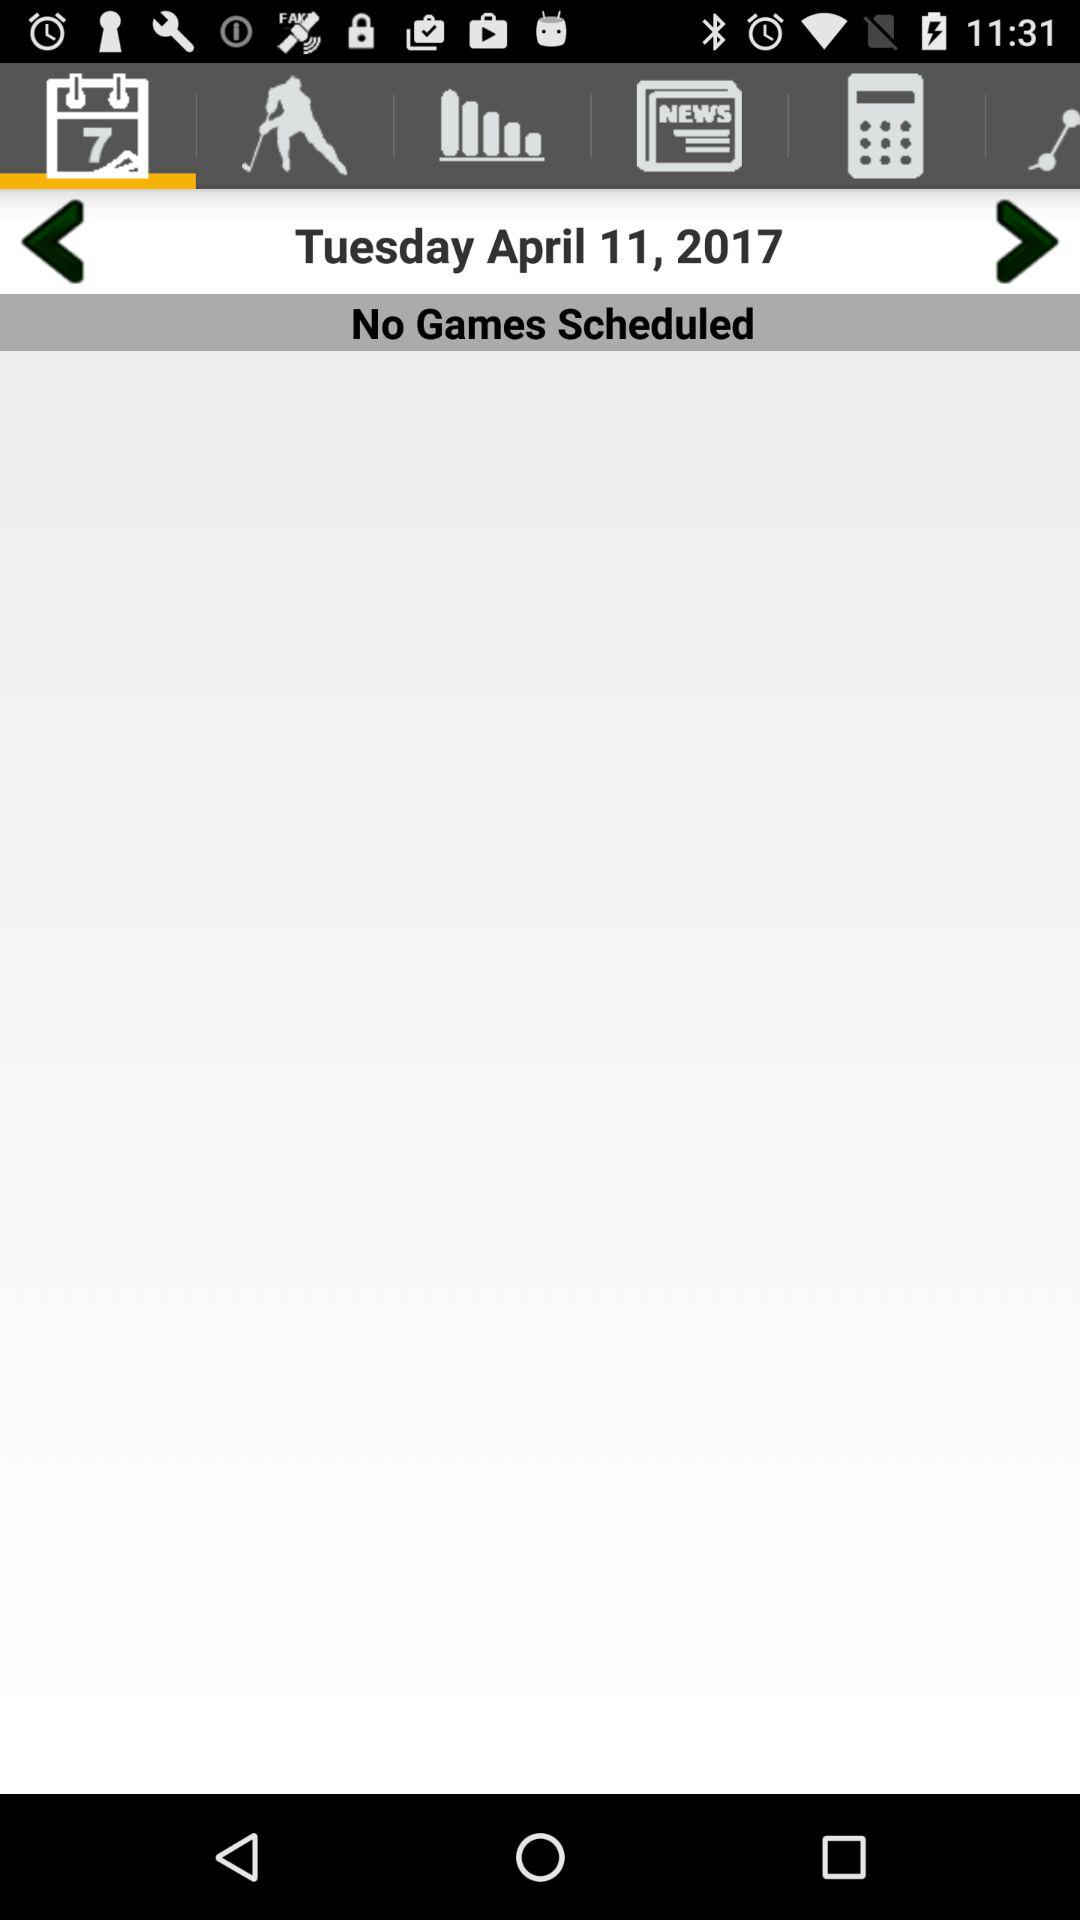Which tab is selected? The selected tab is "Calendar". 